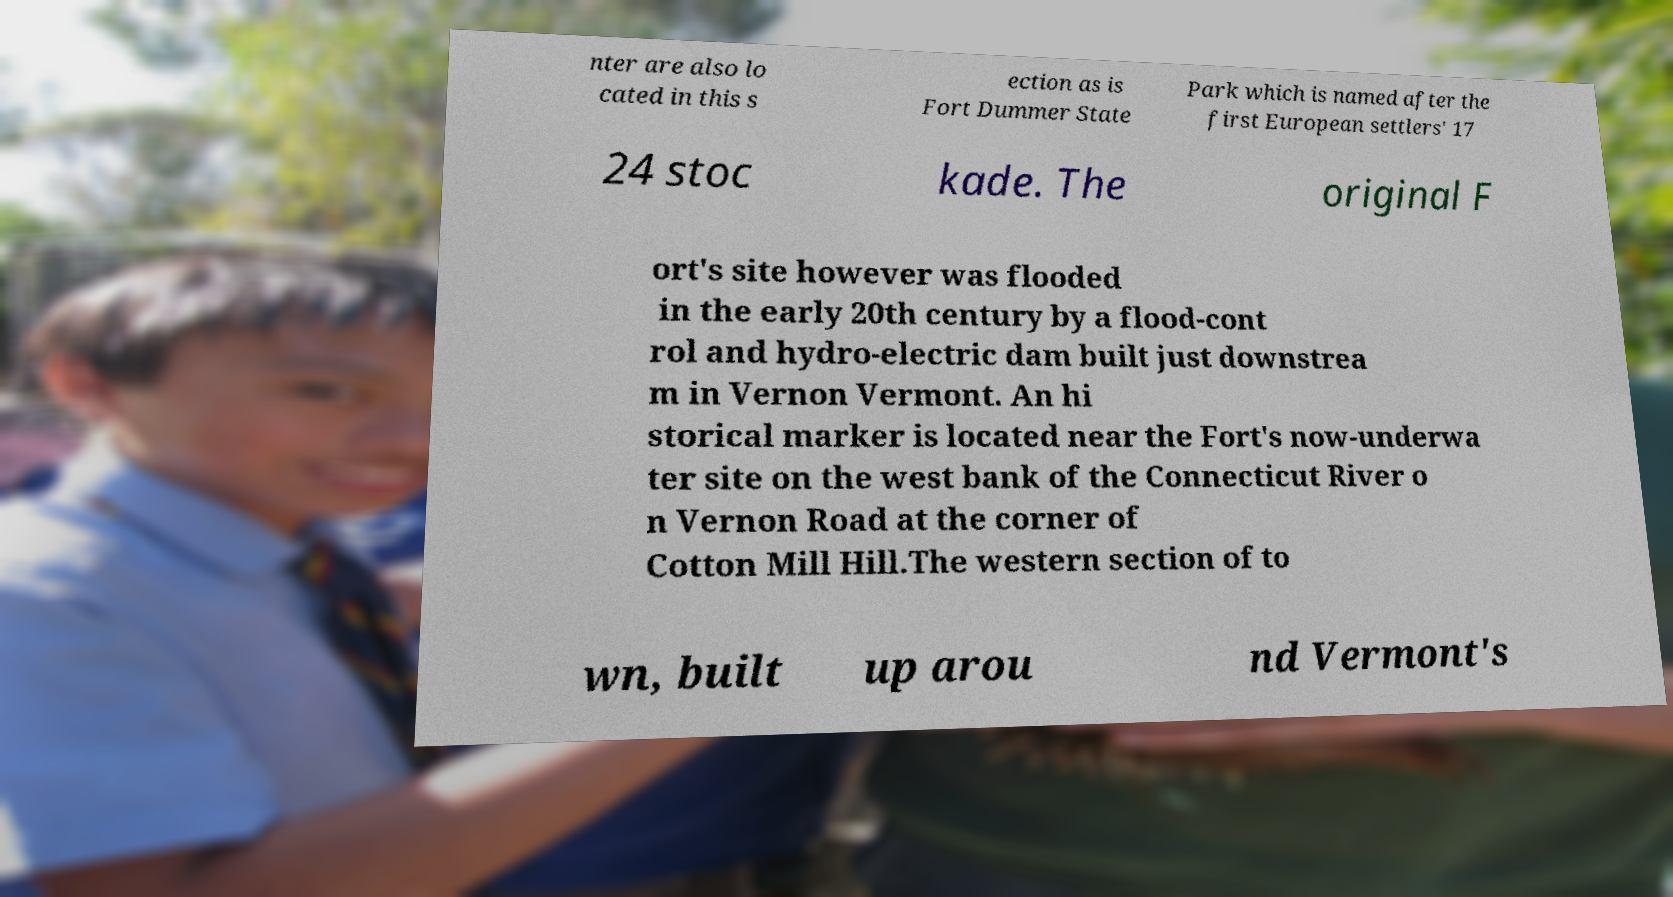For documentation purposes, I need the text within this image transcribed. Could you provide that? nter are also lo cated in this s ection as is Fort Dummer State Park which is named after the first European settlers' 17 24 stoc kade. The original F ort's site however was flooded in the early 20th century by a flood-cont rol and hydro-electric dam built just downstrea m in Vernon Vermont. An hi storical marker is located near the Fort's now-underwa ter site on the west bank of the Connecticut River o n Vernon Road at the corner of Cotton Mill Hill.The western section of to wn, built up arou nd Vermont's 